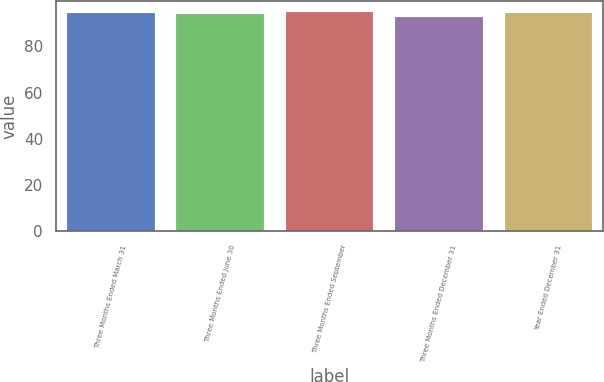Convert chart to OTSL. <chart><loc_0><loc_0><loc_500><loc_500><bar_chart><fcel>Three Months Ended March 31<fcel>Three Months Ended June 30<fcel>Three Months Ended September<fcel>Three Months Ended December 31<fcel>Year Ended December 31<nl><fcel>94.6<fcel>94.1<fcel>95<fcel>92.9<fcel>94.31<nl></chart> 